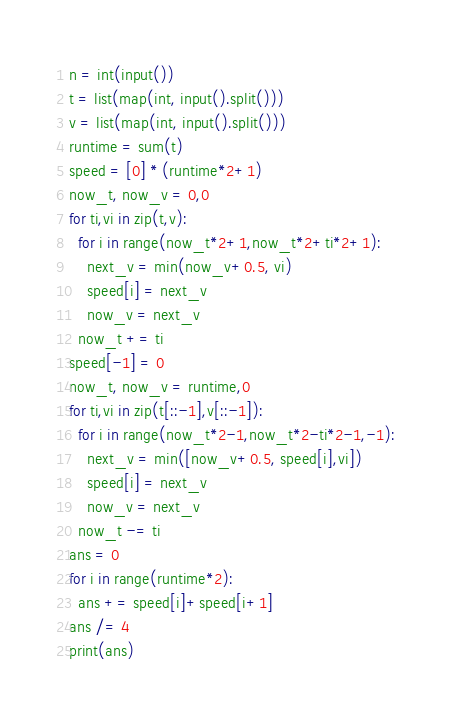<code> <loc_0><loc_0><loc_500><loc_500><_Python_>n = int(input())
t = list(map(int, input().split()))
v = list(map(int, input().split()))
runtime = sum(t)
speed = [0] * (runtime*2+1)
now_t, now_v = 0,0
for ti,vi in zip(t,v):
  for i in range(now_t*2+1,now_t*2+ti*2+1):
    next_v = min(now_v+0.5, vi)
    speed[i] = next_v
    now_v = next_v
  now_t += ti
speed[-1] = 0
now_t, now_v = runtime,0
for ti,vi in zip(t[::-1],v[::-1]):
  for i in range(now_t*2-1,now_t*2-ti*2-1,-1):
    next_v = min([now_v+0.5, speed[i],vi])
    speed[i] = next_v
    now_v = next_v
  now_t -= ti
ans = 0
for i in range(runtime*2):
  ans += speed[i]+speed[i+1]
ans /= 4
print(ans)</code> 